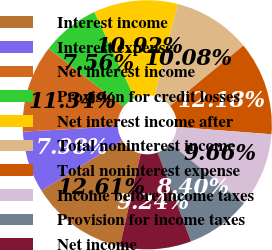Convert chart. <chart><loc_0><loc_0><loc_500><loc_500><pie_chart><fcel>Interest income<fcel>Interest expense<fcel>Net interest income<fcel>Provision for credit losses<fcel>Net interest income after<fcel>Total noninterest income<fcel>Total noninterest expense<fcel>Income before income taxes<fcel>Provision for income taxes<fcel>Net income<nl><fcel>12.61%<fcel>7.98%<fcel>11.34%<fcel>7.56%<fcel>10.92%<fcel>10.08%<fcel>12.18%<fcel>9.66%<fcel>8.4%<fcel>9.24%<nl></chart> 